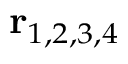<formula> <loc_0><loc_0><loc_500><loc_500>r _ { 1 , 2 , 3 , 4 }</formula> 